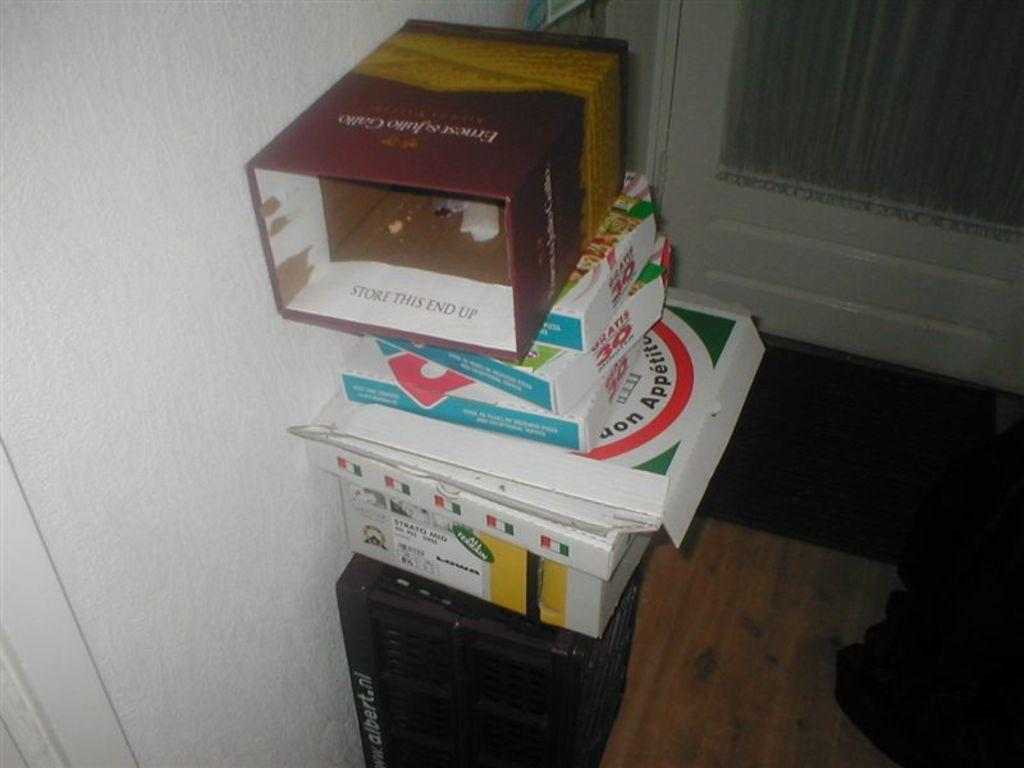<image>
Describe the image concisely. A stack of boxes, the top of which is from Ernest and Julio Gallo. 